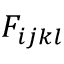Convert formula to latex. <formula><loc_0><loc_0><loc_500><loc_500>F _ { i j k l }</formula> 